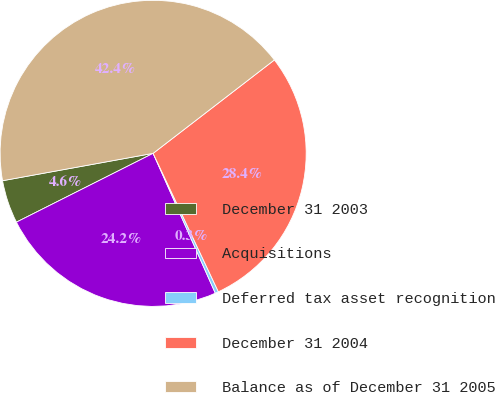Convert chart. <chart><loc_0><loc_0><loc_500><loc_500><pie_chart><fcel>December 31 2003<fcel>Acquisitions<fcel>Deferred tax asset recognition<fcel>December 31 2004<fcel>Balance as of December 31 2005<nl><fcel>4.56%<fcel>24.24%<fcel>0.35%<fcel>28.44%<fcel>42.42%<nl></chart> 